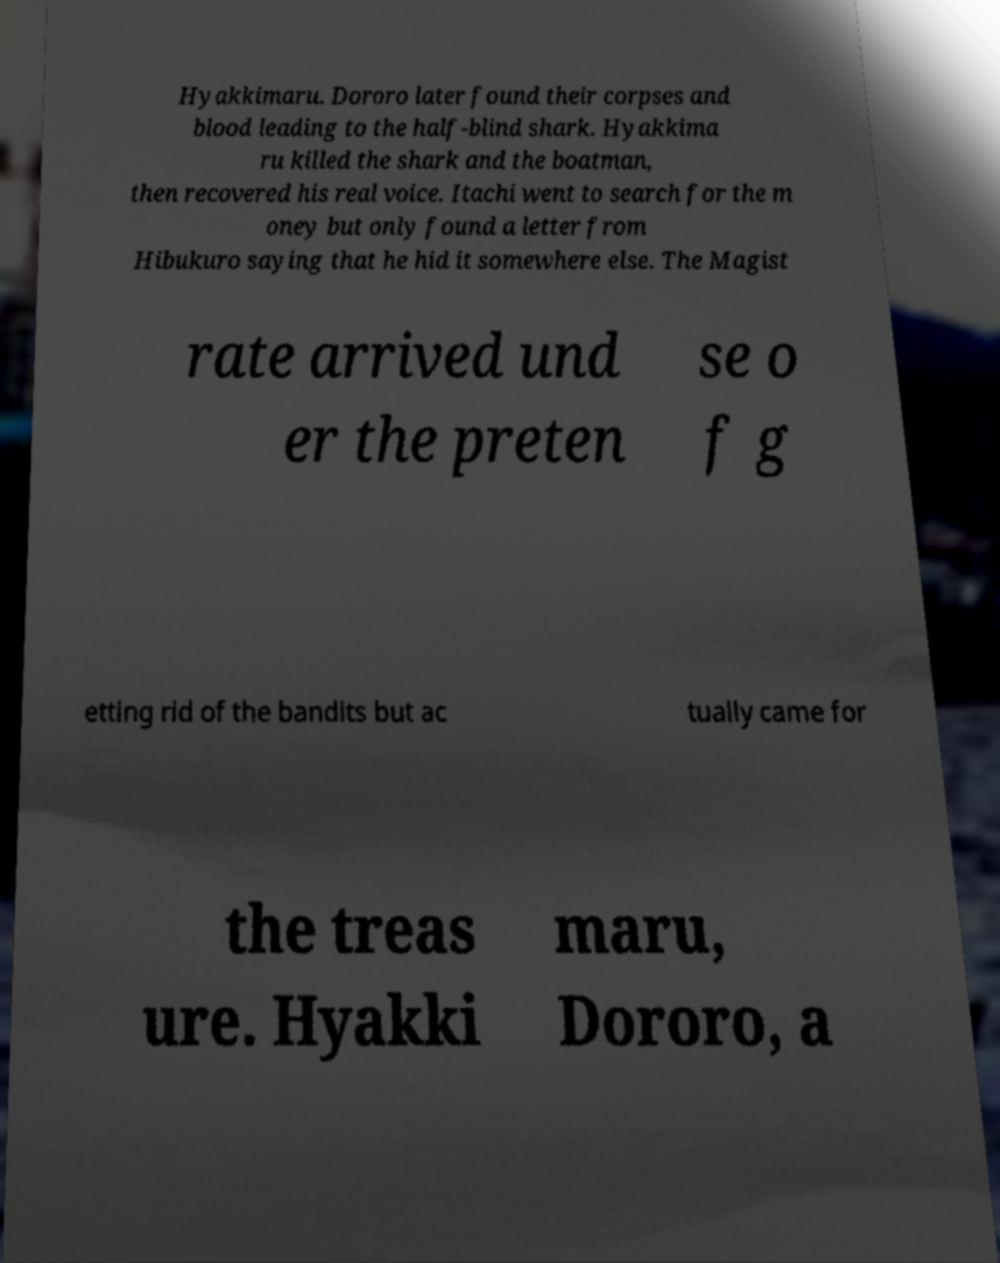I need the written content from this picture converted into text. Can you do that? Hyakkimaru. Dororo later found their corpses and blood leading to the half-blind shark. Hyakkima ru killed the shark and the boatman, then recovered his real voice. Itachi went to search for the m oney but only found a letter from Hibukuro saying that he hid it somewhere else. The Magist rate arrived und er the preten se o f g etting rid of the bandits but ac tually came for the treas ure. Hyakki maru, Dororo, a 